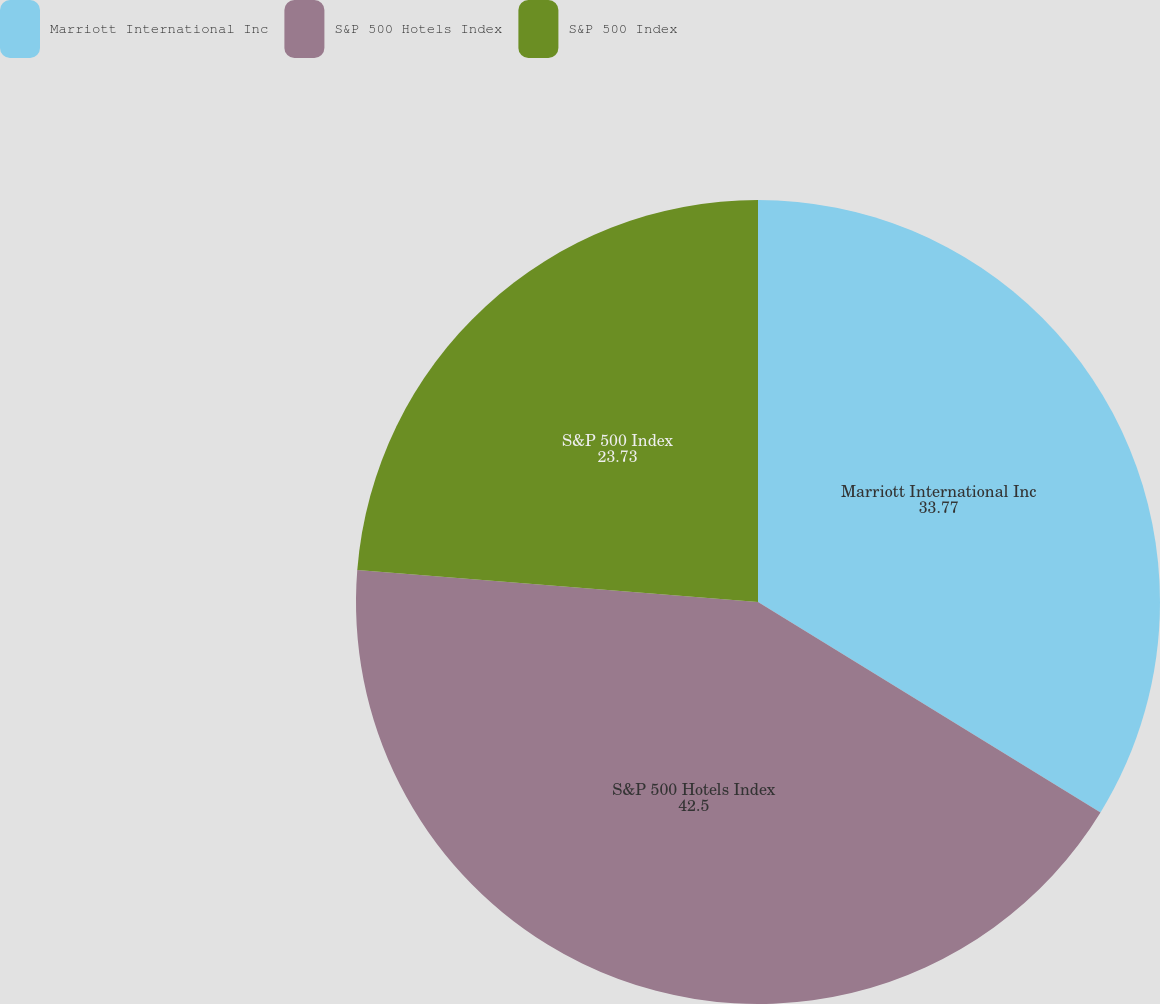<chart> <loc_0><loc_0><loc_500><loc_500><pie_chart><fcel>Marriott International Inc<fcel>S&P 500 Hotels Index<fcel>S&P 500 Index<nl><fcel>33.77%<fcel>42.5%<fcel>23.73%<nl></chart> 